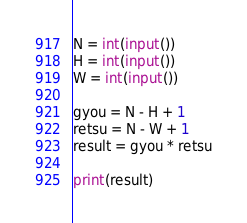<code> <loc_0><loc_0><loc_500><loc_500><_Python_>N = int(input())
H = int(input())
W = int(input())

gyou = N - H + 1
retsu = N - W + 1
result = gyou * retsu

print(result)</code> 